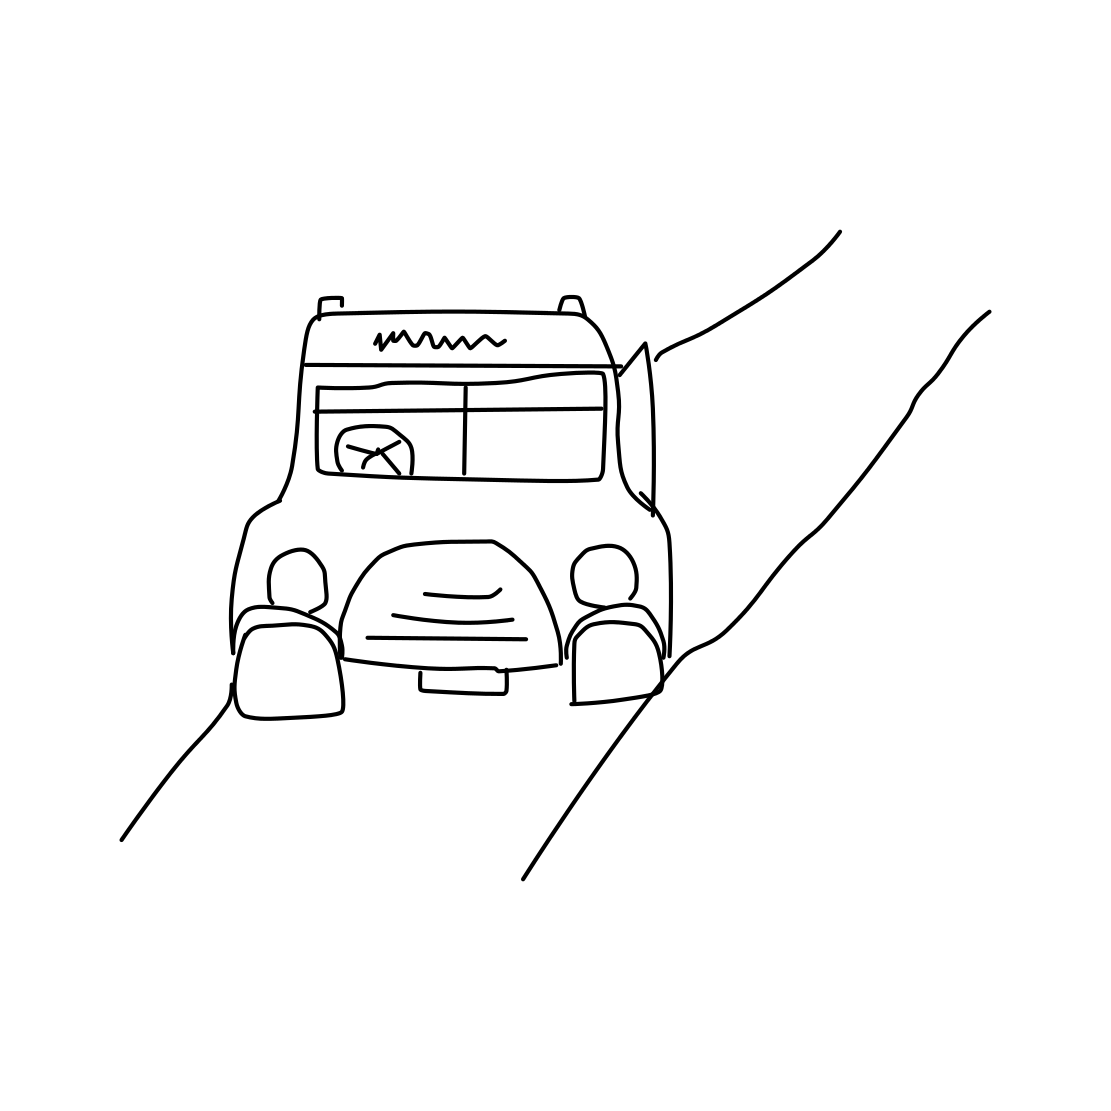Is this a truck in the image? Yes 